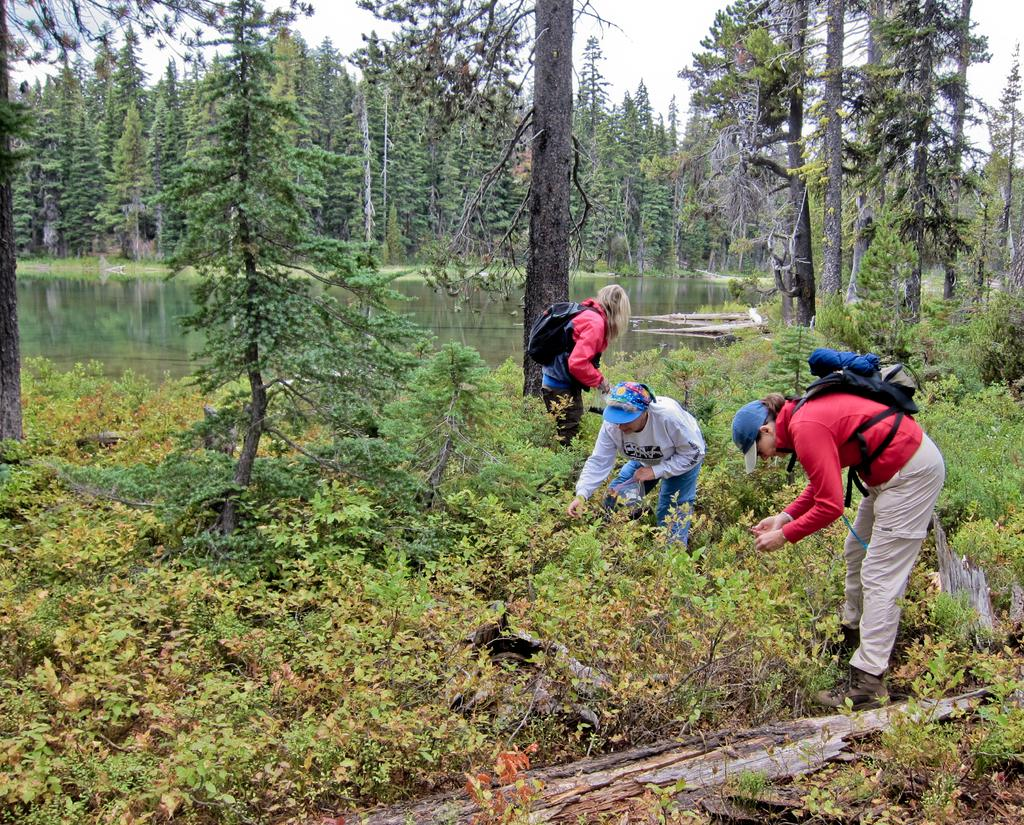How many people are present in the image? There are three people in the image. What else can be seen in the image besides the people? There are plants in the image. What is visible in the background of the image? There are trees, water, and the sky visible in the background of the image. What type of cannon is being used by the people in the image? There is no cannon present in the image; it features three people and various natural elements. Can you describe the wing of the bird in the image? There is no bird or wing present in the image. 